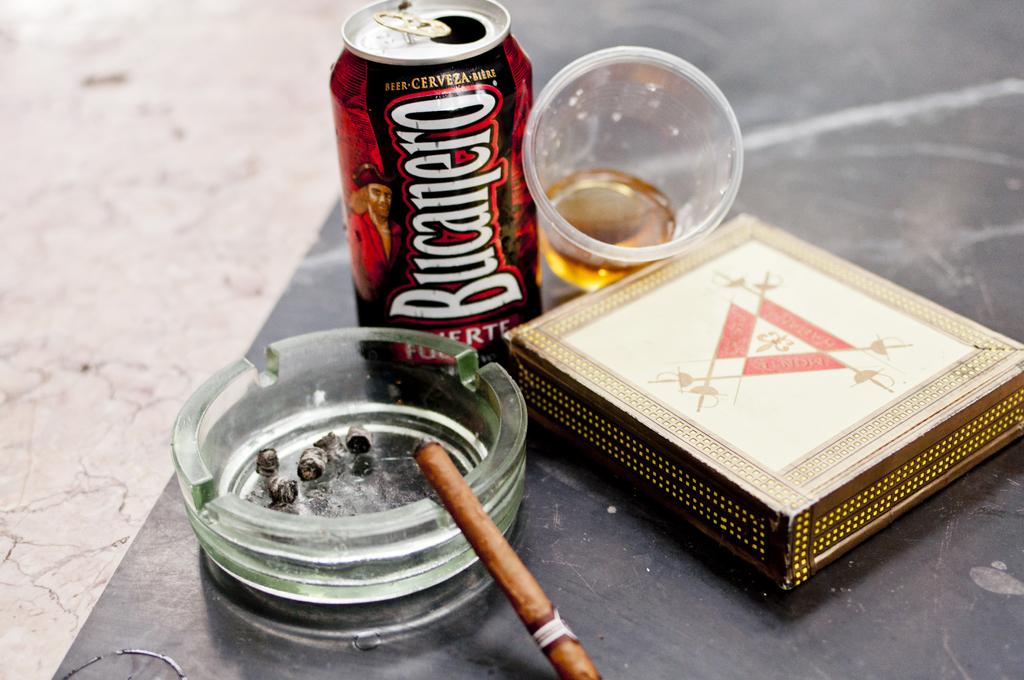What brand of beer is on the table?
Ensure brevity in your answer.  Bucanero. Is there alcohol and drugs in this photo?
Your answer should be compact. Yes. 